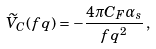<formula> <loc_0><loc_0><loc_500><loc_500>\widetilde { V } _ { C } ( f { q } ) = - \frac { 4 \pi C _ { F } \alpha _ { s } } { f { q } ^ { 2 } } \, ,</formula> 